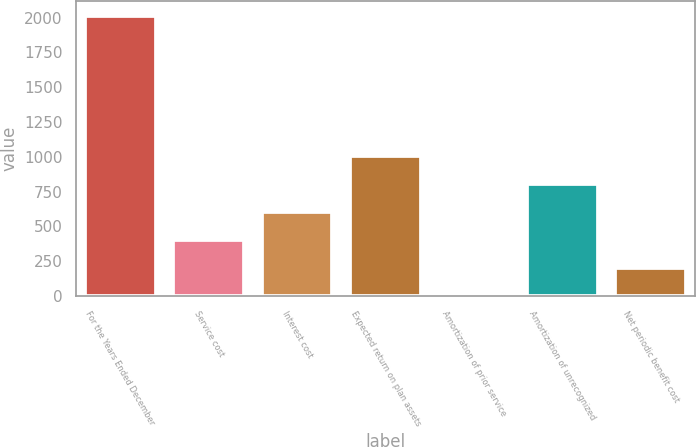Convert chart. <chart><loc_0><loc_0><loc_500><loc_500><bar_chart><fcel>For the Years Ended December<fcel>Service cost<fcel>Interest cost<fcel>Expected return on plan assets<fcel>Amortization of prior service<fcel>Amortization of unrecognized<fcel>Net periodic benefit cost<nl><fcel>2015<fcel>405.96<fcel>607.09<fcel>1009.35<fcel>3.7<fcel>808.22<fcel>204.83<nl></chart> 